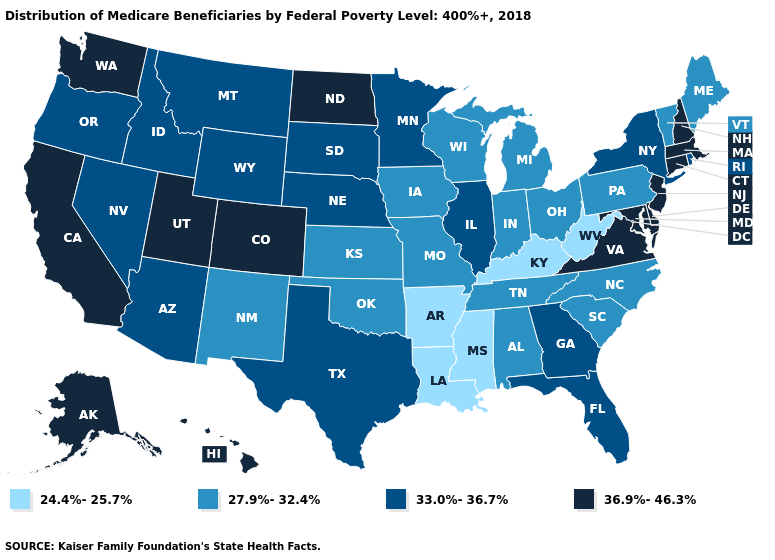Does Alabama have the highest value in the USA?
Quick response, please. No. What is the lowest value in the Northeast?
Write a very short answer. 27.9%-32.4%. What is the lowest value in the MidWest?
Short answer required. 27.9%-32.4%. How many symbols are there in the legend?
Short answer required. 4. Which states have the lowest value in the South?
Answer briefly. Arkansas, Kentucky, Louisiana, Mississippi, West Virginia. What is the value of Tennessee?
Be succinct. 27.9%-32.4%. Name the states that have a value in the range 33.0%-36.7%?
Give a very brief answer. Arizona, Florida, Georgia, Idaho, Illinois, Minnesota, Montana, Nebraska, Nevada, New York, Oregon, Rhode Island, South Dakota, Texas, Wyoming. Is the legend a continuous bar?
Answer briefly. No. Name the states that have a value in the range 36.9%-46.3%?
Keep it brief. Alaska, California, Colorado, Connecticut, Delaware, Hawaii, Maryland, Massachusetts, New Hampshire, New Jersey, North Dakota, Utah, Virginia, Washington. Does Delaware have the highest value in the South?
Short answer required. Yes. What is the value of Wyoming?
Quick response, please. 33.0%-36.7%. Name the states that have a value in the range 24.4%-25.7%?
Answer briefly. Arkansas, Kentucky, Louisiana, Mississippi, West Virginia. 